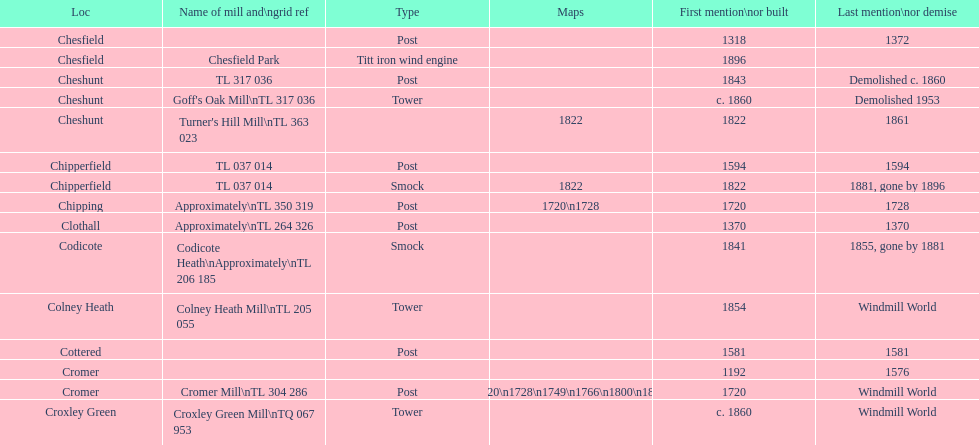What is the number of mills first mentioned or built in the 1800s? 8. 